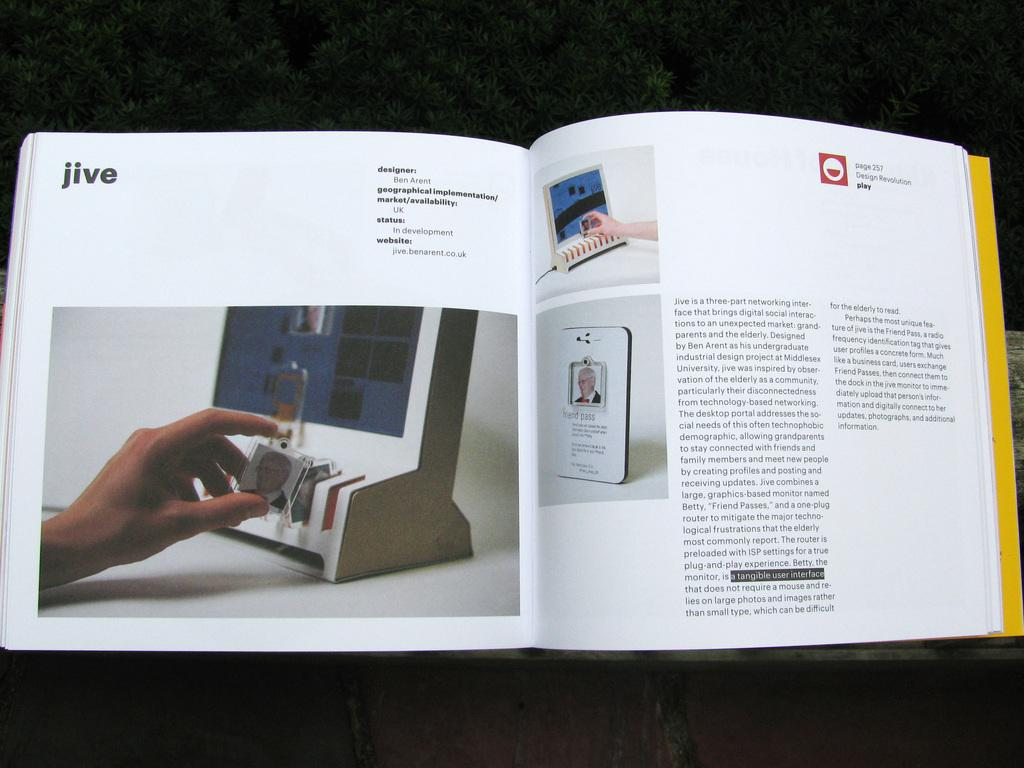<image>
Render a clear and concise summary of the photo. A book is open to page 257 and is titled jive. 